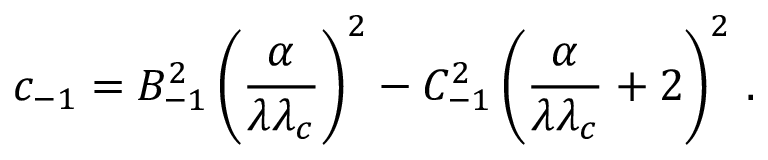Convert formula to latex. <formula><loc_0><loc_0><loc_500><loc_500>c _ { - 1 } = B _ { - 1 } ^ { 2 } \left ( \frac { \alpha } { \lambda \lambda _ { c } } \right ) ^ { 2 } - C _ { - 1 } ^ { 2 } \left ( \frac { \alpha } { \lambda \lambda _ { c } } + 2 \right ) ^ { 2 } \, { . }</formula> 